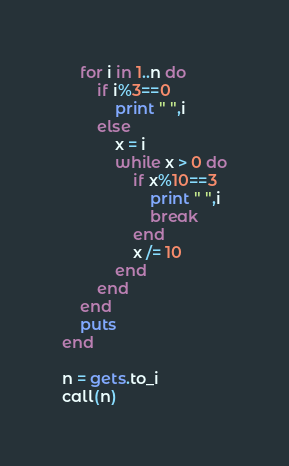<code> <loc_0><loc_0><loc_500><loc_500><_Ruby_>    for i in 1..n do
        if i%3==0
            print " ",i
        else
            x = i
            while x > 0 do
                if x%10==3
                    print " ",i
                    break
                end
                x /= 10
            end
        end
    end
    puts
end

n = gets.to_i
call(n)</code> 